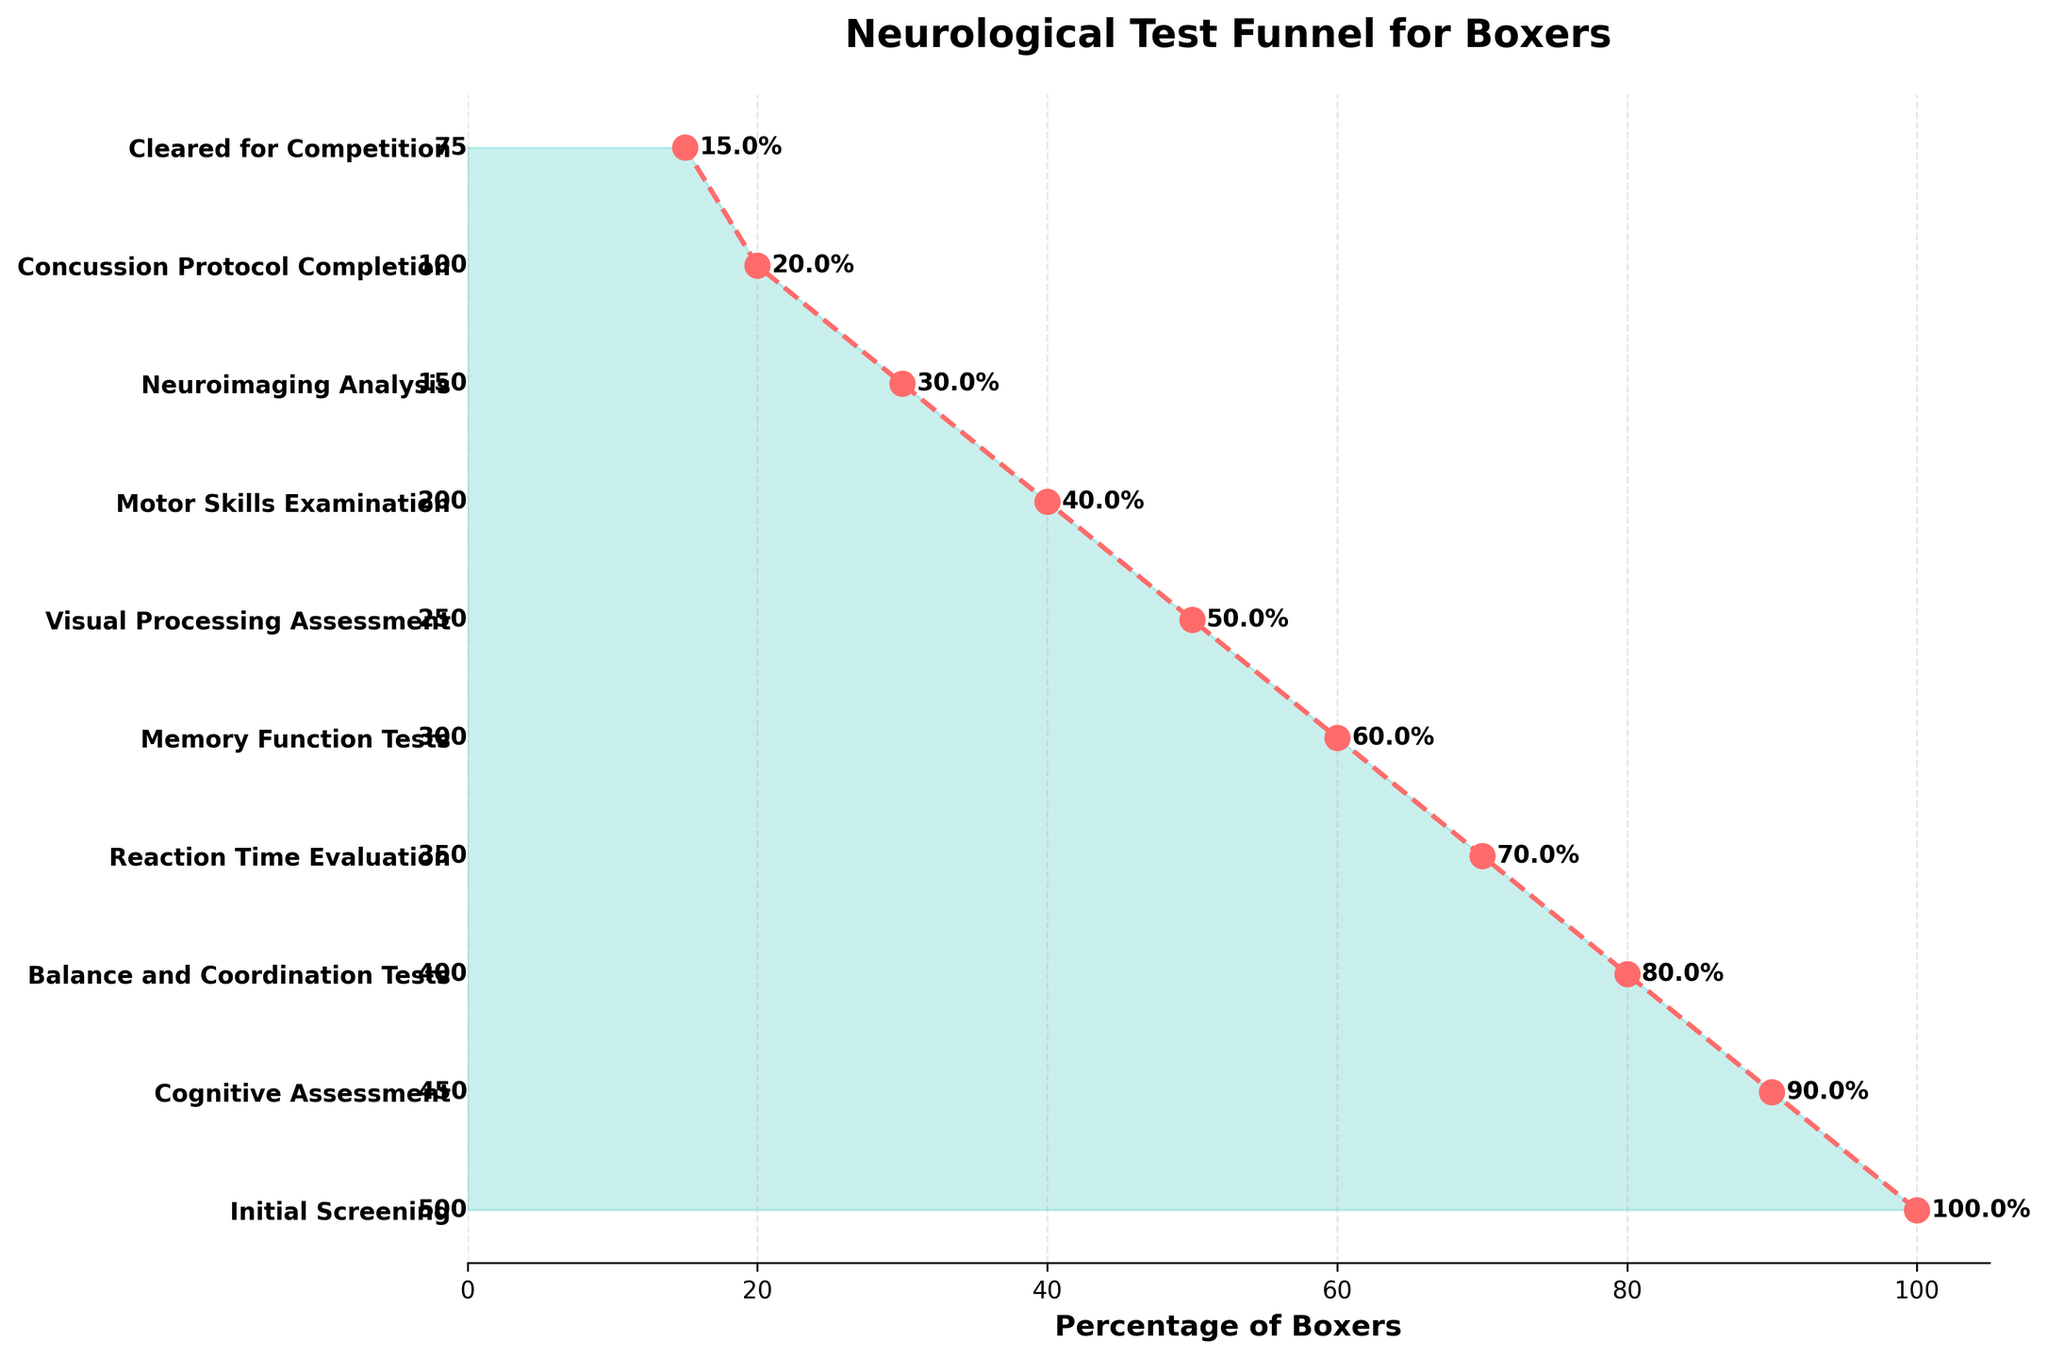What is the title of the figure? The title is typically displayed at the top of the figure, and it provides an overview of what the figure represents. In this case, it says "Neurological Test Funnel for Boxers."
Answer: Neurological Test Funnel for Boxers Which test had the highest number of boxers? Observing the funnel, the leftmost label with the highest number of boxers is "Initial Screening" with 500 boxers.
Answer: Initial Screening How many stages of neurological testing are illustrated in the figure? Count all the distinct stages listed on the y-axis from top to bottom. There are ten stages shown in the figure.
Answer: 10 What percentage of boxers make it through the Memory Function Tests stage? Locate the "Memory Function Tests" stage and note the percentage value labeled beside it. The labeled percentage here is 60%.
Answer: 60% How many boxers moved from the Balance and Coordination Tests to the Reaction Time Evaluation? The number of boxers at "Balance and Coordination Tests" is 400. The number at "Reaction Time Evaluation" is 350. The difference is 400 - 350 = 50.
Answer: 50 What is the drop-off rate between the Initial Screening and Cognitive Assessment stages? Initial Screening had 500 boxers and Cognitive Assessment had 450 boxers. The drop-off is calculated as (500 - 450) / 500 * 100, which equals 10%.
Answer: 10% Which stage shows the largest percentage drop in boxers? Compare the percentage drops between each consecutive stage. The largest percentage drop is observed going from "Memory Function Tests" (60%) to "Visual Processing Assessment" (50%), which is a 10% drop.
Answer: Memory Function Tests to Visual Processing Assessment How many boxers are present at the final stage, Cleared for Competition? Directly read from the y-axis label for "Cleared for Competition," the number shown is 75.
Answer: 75 What is the total number of boxers lost between the Neuroimaging Analysis and Concussion Protocol Completion stages? Neuroimaging Analysis has 150 boxers, and Concussion Protocol Completion has 100 boxers. The number lost is 150 - 100 = 50.
Answer: 50 Arrange the stages in descending order of the number of boxers. Read the number of boxers for each stage and list them in descending order: 1) Initial Screening, 2) Cognitive Assessment, 3) Balance and Coordination Tests, 4) Reaction Time Evaluation, 5) Memory Function Tests, 6) Visual Processing Assessment, 7) Motor Skills Examination, 8) Neuroimaging Analysis, 9) Concussion Protocol Completion, 10) Cleared for Competition.
Answer: Initial Screening, Cognitive Assessment, Balance and Coordination Tests, Reaction Time Evaluation, Memory Function Tests, Visual Processing Assessment, Motor Skills Examination, Neuroimaging Analysis, Concussion Protocol Completion, Cleared for Competition 